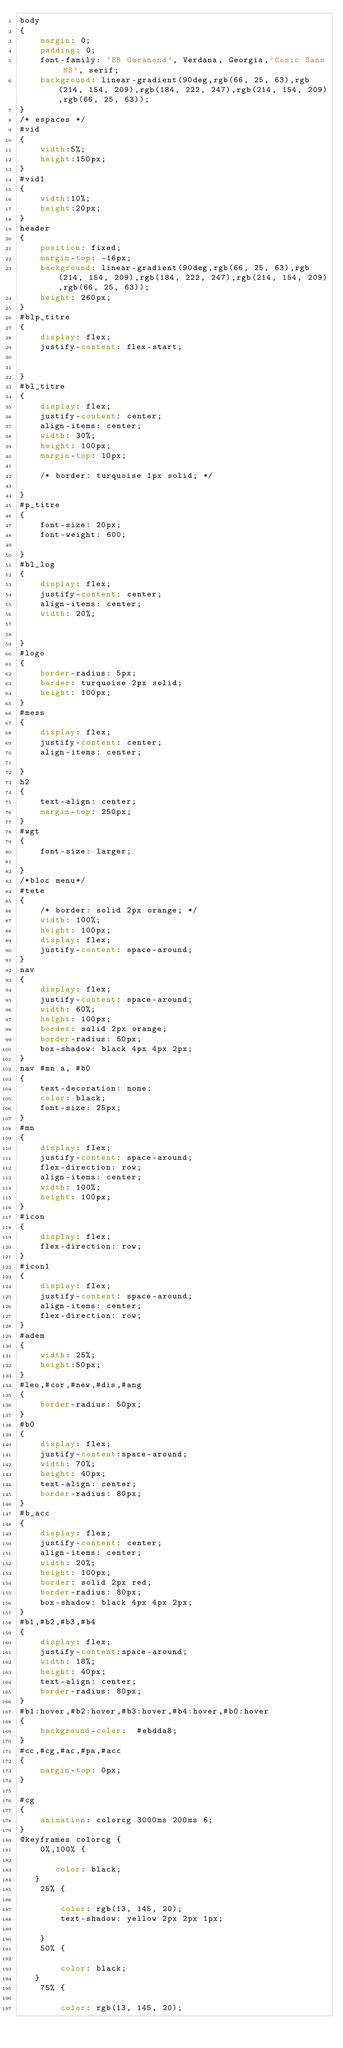Convert code to text. <code><loc_0><loc_0><loc_500><loc_500><_CSS_>body
{
    margin: 0;
    padding: 0;
    font-family: 'EB Garamond', Verdana, Georgia,'Comic Sans MS', serif;
    background: linear-gradient(90deg,rgb(66, 25, 63),rgb(214, 154, 209),rgb(184, 222, 247),rgb(214, 154, 209),rgb(66, 25, 63));
}
/* espaces */
#vid
{
    width:5%;
    height:150px;
}
#vid1
{
    width:10%;
    height:20px;
}
header
{
    position: fixed;
    margin-top: -16px;
    background: linear-gradient(90deg,rgb(66, 25, 63),rgb(214, 154, 209),rgb(184, 222, 247),rgb(214, 154, 209),rgb(66, 25, 63)); 
    height: 260px;
}
#blp_titre
{
    display: flex;
    justify-content: flex-start; 
   
    
}
#bl_titre
{
    display: flex;
    justify-content: center;
    align-items: center;
    width: 30%;
    height: 100px;
    margin-top: 10px;
    
    /* border: turquoise 1px solid; */
    
}
#p_titre
{
    font-size: 20px;
    font-weight: 600;
    
}
#bl_log
{
    display: flex;
    justify-content: center;
    align-items: center;
    width: 20%;
    
   
}
#logo
{
    border-radius: 5px;
    border: turquoise 2px solid;
    height: 100px;
}
#mess
{
    display: flex;
    justify-content: center;
    align-items: center;
   
}
h2
{
    text-align: center;
    margin-top: 250px;
}
#wgt
{
    font-size: larger;
    
}
/*bloc menu*/
#tete
{
    /* border: solid 2px orange; */
    width: 100%;
    height: 100px;
    display: flex;
    justify-content: space-around;
}
nav
{
    display: flex;
    justify-content: space-around;
    width: 60%;
    height: 100px;
    border: solid 2px orange;
    border-radius: 50px;
    box-shadow: black 4px 4px 2px;
}
nav #mn a, #b0
{
    text-decoration: none;
    color: black;
    font-size: 25px;
}
#mn
{
    display: flex;
    justify-content: space-around;
    flex-direction: row;
    align-items: center;
    width: 100%;
    height: 100px;
}
#icon
{
    display: flex;
    flex-direction: row;
}
#icon1
{
    display: flex;
    justify-content: space-around;
    align-items: center;
    flex-direction: row;
}
#adem
{
    width: 25%;
    height:50px;
}
#leo,#cor,#new,#dis,#ang
{
    border-radius: 50px;
}
#b0
{
    display: flex;
    justify-content:space-around;
    width: 70%;
    height: 40px;
    text-align: center;
    border-radius: 80px;
}
#b_acc
{
    display: flex;
    justify-content: center;
    align-items: center;
    width: 20%;
    height: 100px;
    border: solid 2px red;
    border-radius: 80px;
    box-shadow: black 4px 4px 2px;
}
#b1,#b2,#b3,#b4
{
    display: flex;
    justify-content:space-around;
    width: 18%;
    height: 40px;
    text-align: center;
    border-radius: 80px;
}
#b1:hover,#b2:hover,#b3:hover,#b4:hover,#b0:hover
{ 
    background-color:  #ebdda8;
}
#cc,#cg,#ac,#pa,#acc
{
    margin-top: 0px;
}

#cg
{
    animation: colorcg 3000ms 200ms 6;
}
@keyframes colorcg {
    0%,100% {

       color: black;
   }
    25% {
         
        color: rgb(13, 145, 20);
        text-shadow: yellow 2px 2px 1px;

    }
    50% {
        
        color: black;
   }
    75% {
         
        color: rgb(13, 145, 20);</code> 